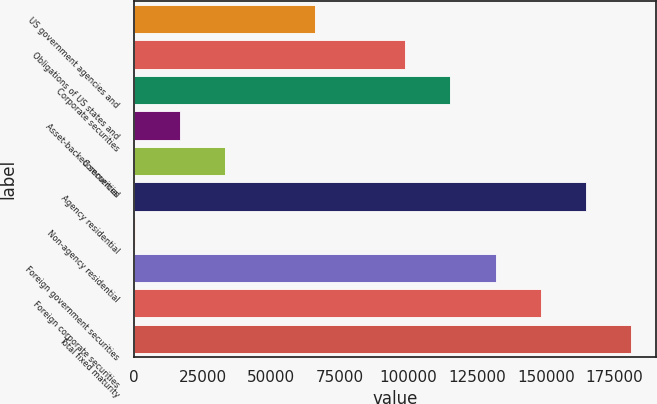<chart> <loc_0><loc_0><loc_500><loc_500><bar_chart><fcel>US government agencies and<fcel>Obligations of US states and<fcel>Corporate securities<fcel>Asset-backed securities<fcel>Commercial<fcel>Agency residential<fcel>Non-agency residential<fcel>Foreign government securities<fcel>Foreign corporate securities<fcel>Total fixed maturity<nl><fcel>65973.6<fcel>98847.4<fcel>115284<fcel>16662.9<fcel>33099.8<fcel>164595<fcel>226<fcel>131721<fcel>148158<fcel>181032<nl></chart> 